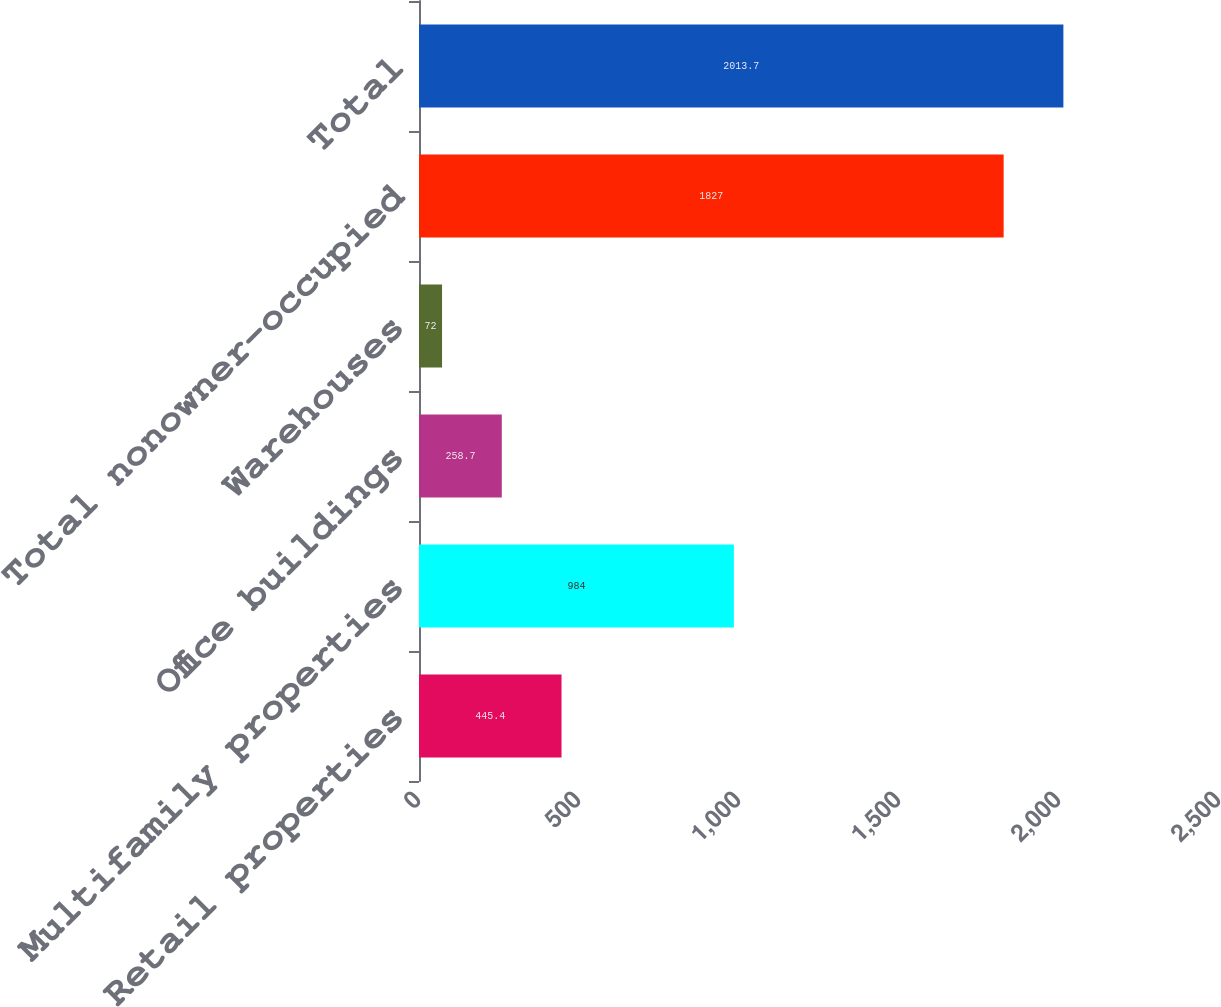Convert chart to OTSL. <chart><loc_0><loc_0><loc_500><loc_500><bar_chart><fcel>Retail properties<fcel>Multifamily properties<fcel>Office buildings<fcel>Warehouses<fcel>Total nonowner-occupied<fcel>Total<nl><fcel>445.4<fcel>984<fcel>258.7<fcel>72<fcel>1827<fcel>2013.7<nl></chart> 